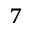<formula> <loc_0><loc_0><loc_500><loc_500>^ { 7 }</formula> 